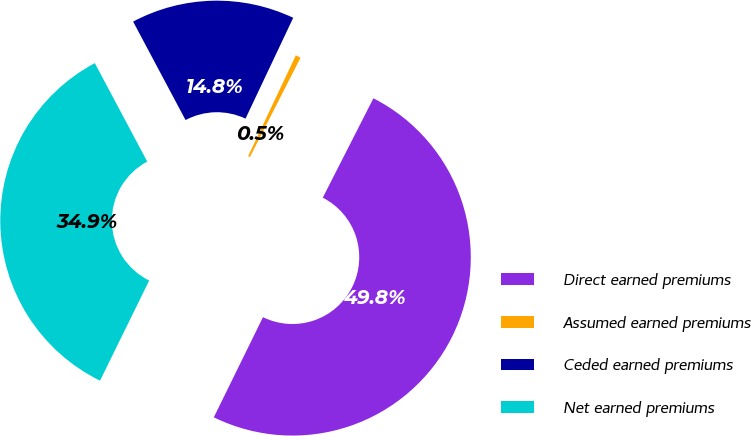<chart> <loc_0><loc_0><loc_500><loc_500><pie_chart><fcel>Direct earned premiums<fcel>Assumed earned premiums<fcel>Ceded earned premiums<fcel>Net earned premiums<nl><fcel>49.77%<fcel>0.47%<fcel>14.82%<fcel>34.95%<nl></chart> 